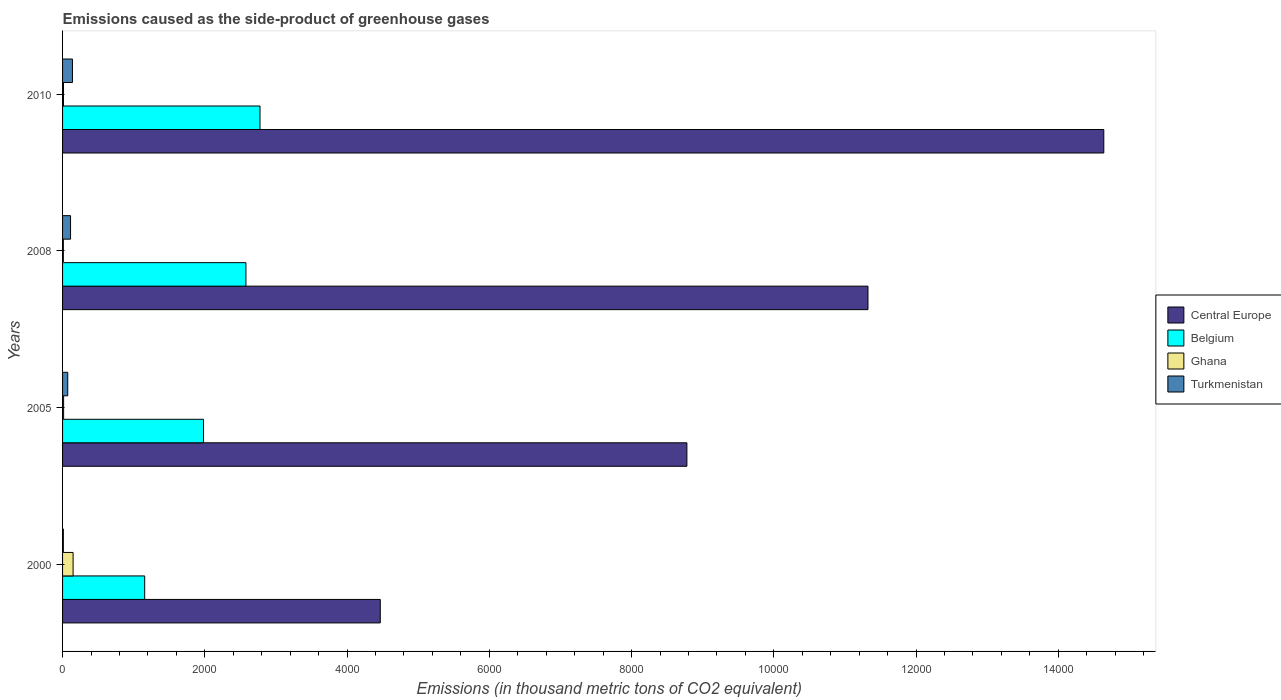How many different coloured bars are there?
Your answer should be very brief. 4. How many groups of bars are there?
Provide a succinct answer. 4. How many bars are there on the 3rd tick from the bottom?
Your response must be concise. 4. What is the emissions caused as the side-product of greenhouse gases in Belgium in 2000?
Ensure brevity in your answer.  1154.6. Across all years, what is the maximum emissions caused as the side-product of greenhouse gases in Ghana?
Your answer should be compact. 148. What is the total emissions caused as the side-product of greenhouse gases in Belgium in the graph?
Provide a succinct answer. 8489.8. What is the difference between the emissions caused as the side-product of greenhouse gases in Belgium in 2005 and that in 2008?
Your answer should be compact. -596.8. What is the difference between the emissions caused as the side-product of greenhouse gases in Ghana in 2010 and the emissions caused as the side-product of greenhouse gases in Central Europe in 2005?
Provide a short and direct response. -8764.6. What is the average emissions caused as the side-product of greenhouse gases in Belgium per year?
Your response must be concise. 2122.45. In the year 2000, what is the difference between the emissions caused as the side-product of greenhouse gases in Ghana and emissions caused as the side-product of greenhouse gases in Central Europe?
Provide a succinct answer. -4318.9. What is the ratio of the emissions caused as the side-product of greenhouse gases in Belgium in 2005 to that in 2010?
Make the answer very short. 0.71. Is the emissions caused as the side-product of greenhouse gases in Ghana in 2000 less than that in 2005?
Provide a short and direct response. No. Is the difference between the emissions caused as the side-product of greenhouse gases in Ghana in 2008 and 2010 greater than the difference between the emissions caused as the side-product of greenhouse gases in Central Europe in 2008 and 2010?
Provide a succinct answer. Yes. What is the difference between the highest and the second highest emissions caused as the side-product of greenhouse gases in Belgium?
Your response must be concise. 198. What is the difference between the highest and the lowest emissions caused as the side-product of greenhouse gases in Ghana?
Ensure brevity in your answer.  136.8. In how many years, is the emissions caused as the side-product of greenhouse gases in Belgium greater than the average emissions caused as the side-product of greenhouse gases in Belgium taken over all years?
Make the answer very short. 2. Is the sum of the emissions caused as the side-product of greenhouse gases in Turkmenistan in 2000 and 2010 greater than the maximum emissions caused as the side-product of greenhouse gases in Ghana across all years?
Offer a very short reply. Yes. Is it the case that in every year, the sum of the emissions caused as the side-product of greenhouse gases in Central Europe and emissions caused as the side-product of greenhouse gases in Belgium is greater than the sum of emissions caused as the side-product of greenhouse gases in Turkmenistan and emissions caused as the side-product of greenhouse gases in Ghana?
Offer a terse response. No. How many bars are there?
Your answer should be very brief. 16. Are all the bars in the graph horizontal?
Keep it short and to the point. Yes. How many years are there in the graph?
Your answer should be compact. 4. What is the difference between two consecutive major ticks on the X-axis?
Provide a succinct answer. 2000. Are the values on the major ticks of X-axis written in scientific E-notation?
Provide a short and direct response. No. Does the graph contain any zero values?
Make the answer very short. No. What is the title of the graph?
Offer a terse response. Emissions caused as the side-product of greenhouse gases. What is the label or title of the X-axis?
Provide a succinct answer. Emissions (in thousand metric tons of CO2 equivalent). What is the label or title of the Y-axis?
Provide a succinct answer. Years. What is the Emissions (in thousand metric tons of CO2 equivalent) in Central Europe in 2000?
Your response must be concise. 4466.9. What is the Emissions (in thousand metric tons of CO2 equivalent) in Belgium in 2000?
Keep it short and to the point. 1154.6. What is the Emissions (in thousand metric tons of CO2 equivalent) of Ghana in 2000?
Your response must be concise. 148. What is the Emissions (in thousand metric tons of CO2 equivalent) of Central Europe in 2005?
Offer a terse response. 8777.6. What is the Emissions (in thousand metric tons of CO2 equivalent) of Belgium in 2005?
Give a very brief answer. 1981.2. What is the Emissions (in thousand metric tons of CO2 equivalent) in Turkmenistan in 2005?
Your answer should be compact. 72.9. What is the Emissions (in thousand metric tons of CO2 equivalent) in Central Europe in 2008?
Ensure brevity in your answer.  1.13e+04. What is the Emissions (in thousand metric tons of CO2 equivalent) of Belgium in 2008?
Provide a short and direct response. 2578. What is the Emissions (in thousand metric tons of CO2 equivalent) in Turkmenistan in 2008?
Your response must be concise. 112.2. What is the Emissions (in thousand metric tons of CO2 equivalent) in Central Europe in 2010?
Offer a very short reply. 1.46e+04. What is the Emissions (in thousand metric tons of CO2 equivalent) in Belgium in 2010?
Offer a very short reply. 2776. What is the Emissions (in thousand metric tons of CO2 equivalent) of Turkmenistan in 2010?
Make the answer very short. 139. Across all years, what is the maximum Emissions (in thousand metric tons of CO2 equivalent) of Central Europe?
Ensure brevity in your answer.  1.46e+04. Across all years, what is the maximum Emissions (in thousand metric tons of CO2 equivalent) of Belgium?
Your answer should be compact. 2776. Across all years, what is the maximum Emissions (in thousand metric tons of CO2 equivalent) in Ghana?
Make the answer very short. 148. Across all years, what is the maximum Emissions (in thousand metric tons of CO2 equivalent) of Turkmenistan?
Give a very brief answer. 139. Across all years, what is the minimum Emissions (in thousand metric tons of CO2 equivalent) of Central Europe?
Offer a very short reply. 4466.9. Across all years, what is the minimum Emissions (in thousand metric tons of CO2 equivalent) in Belgium?
Your answer should be compact. 1154.6. Across all years, what is the minimum Emissions (in thousand metric tons of CO2 equivalent) of Turkmenistan?
Give a very brief answer. 10.9. What is the total Emissions (in thousand metric tons of CO2 equivalent) in Central Europe in the graph?
Keep it short and to the point. 3.92e+04. What is the total Emissions (in thousand metric tons of CO2 equivalent) in Belgium in the graph?
Provide a succinct answer. 8489.8. What is the total Emissions (in thousand metric tons of CO2 equivalent) of Ghana in the graph?
Offer a very short reply. 186.9. What is the total Emissions (in thousand metric tons of CO2 equivalent) in Turkmenistan in the graph?
Offer a very short reply. 335. What is the difference between the Emissions (in thousand metric tons of CO2 equivalent) of Central Europe in 2000 and that in 2005?
Provide a succinct answer. -4310.7. What is the difference between the Emissions (in thousand metric tons of CO2 equivalent) in Belgium in 2000 and that in 2005?
Keep it short and to the point. -826.6. What is the difference between the Emissions (in thousand metric tons of CO2 equivalent) in Ghana in 2000 and that in 2005?
Your answer should be compact. 133.3. What is the difference between the Emissions (in thousand metric tons of CO2 equivalent) in Turkmenistan in 2000 and that in 2005?
Make the answer very short. -62. What is the difference between the Emissions (in thousand metric tons of CO2 equivalent) in Central Europe in 2000 and that in 2008?
Your answer should be compact. -6856.5. What is the difference between the Emissions (in thousand metric tons of CO2 equivalent) of Belgium in 2000 and that in 2008?
Your response must be concise. -1423.4. What is the difference between the Emissions (in thousand metric tons of CO2 equivalent) of Ghana in 2000 and that in 2008?
Your answer should be compact. 136.8. What is the difference between the Emissions (in thousand metric tons of CO2 equivalent) of Turkmenistan in 2000 and that in 2008?
Keep it short and to the point. -101.3. What is the difference between the Emissions (in thousand metric tons of CO2 equivalent) in Central Europe in 2000 and that in 2010?
Provide a short and direct response. -1.02e+04. What is the difference between the Emissions (in thousand metric tons of CO2 equivalent) in Belgium in 2000 and that in 2010?
Give a very brief answer. -1621.4. What is the difference between the Emissions (in thousand metric tons of CO2 equivalent) of Ghana in 2000 and that in 2010?
Make the answer very short. 135. What is the difference between the Emissions (in thousand metric tons of CO2 equivalent) in Turkmenistan in 2000 and that in 2010?
Your response must be concise. -128.1. What is the difference between the Emissions (in thousand metric tons of CO2 equivalent) of Central Europe in 2005 and that in 2008?
Provide a succinct answer. -2545.8. What is the difference between the Emissions (in thousand metric tons of CO2 equivalent) of Belgium in 2005 and that in 2008?
Your answer should be compact. -596.8. What is the difference between the Emissions (in thousand metric tons of CO2 equivalent) in Ghana in 2005 and that in 2008?
Keep it short and to the point. 3.5. What is the difference between the Emissions (in thousand metric tons of CO2 equivalent) in Turkmenistan in 2005 and that in 2008?
Offer a very short reply. -39.3. What is the difference between the Emissions (in thousand metric tons of CO2 equivalent) of Central Europe in 2005 and that in 2010?
Offer a terse response. -5861.4. What is the difference between the Emissions (in thousand metric tons of CO2 equivalent) of Belgium in 2005 and that in 2010?
Your response must be concise. -794.8. What is the difference between the Emissions (in thousand metric tons of CO2 equivalent) in Ghana in 2005 and that in 2010?
Give a very brief answer. 1.7. What is the difference between the Emissions (in thousand metric tons of CO2 equivalent) of Turkmenistan in 2005 and that in 2010?
Your answer should be compact. -66.1. What is the difference between the Emissions (in thousand metric tons of CO2 equivalent) in Central Europe in 2008 and that in 2010?
Keep it short and to the point. -3315.6. What is the difference between the Emissions (in thousand metric tons of CO2 equivalent) of Belgium in 2008 and that in 2010?
Offer a terse response. -198. What is the difference between the Emissions (in thousand metric tons of CO2 equivalent) of Ghana in 2008 and that in 2010?
Provide a short and direct response. -1.8. What is the difference between the Emissions (in thousand metric tons of CO2 equivalent) in Turkmenistan in 2008 and that in 2010?
Your answer should be compact. -26.8. What is the difference between the Emissions (in thousand metric tons of CO2 equivalent) in Central Europe in 2000 and the Emissions (in thousand metric tons of CO2 equivalent) in Belgium in 2005?
Keep it short and to the point. 2485.7. What is the difference between the Emissions (in thousand metric tons of CO2 equivalent) in Central Europe in 2000 and the Emissions (in thousand metric tons of CO2 equivalent) in Ghana in 2005?
Give a very brief answer. 4452.2. What is the difference between the Emissions (in thousand metric tons of CO2 equivalent) in Central Europe in 2000 and the Emissions (in thousand metric tons of CO2 equivalent) in Turkmenistan in 2005?
Offer a terse response. 4394. What is the difference between the Emissions (in thousand metric tons of CO2 equivalent) of Belgium in 2000 and the Emissions (in thousand metric tons of CO2 equivalent) of Ghana in 2005?
Offer a very short reply. 1139.9. What is the difference between the Emissions (in thousand metric tons of CO2 equivalent) in Belgium in 2000 and the Emissions (in thousand metric tons of CO2 equivalent) in Turkmenistan in 2005?
Give a very brief answer. 1081.7. What is the difference between the Emissions (in thousand metric tons of CO2 equivalent) of Ghana in 2000 and the Emissions (in thousand metric tons of CO2 equivalent) of Turkmenistan in 2005?
Give a very brief answer. 75.1. What is the difference between the Emissions (in thousand metric tons of CO2 equivalent) of Central Europe in 2000 and the Emissions (in thousand metric tons of CO2 equivalent) of Belgium in 2008?
Ensure brevity in your answer.  1888.9. What is the difference between the Emissions (in thousand metric tons of CO2 equivalent) of Central Europe in 2000 and the Emissions (in thousand metric tons of CO2 equivalent) of Ghana in 2008?
Offer a terse response. 4455.7. What is the difference between the Emissions (in thousand metric tons of CO2 equivalent) of Central Europe in 2000 and the Emissions (in thousand metric tons of CO2 equivalent) of Turkmenistan in 2008?
Your response must be concise. 4354.7. What is the difference between the Emissions (in thousand metric tons of CO2 equivalent) of Belgium in 2000 and the Emissions (in thousand metric tons of CO2 equivalent) of Ghana in 2008?
Provide a short and direct response. 1143.4. What is the difference between the Emissions (in thousand metric tons of CO2 equivalent) of Belgium in 2000 and the Emissions (in thousand metric tons of CO2 equivalent) of Turkmenistan in 2008?
Your answer should be very brief. 1042.4. What is the difference between the Emissions (in thousand metric tons of CO2 equivalent) in Ghana in 2000 and the Emissions (in thousand metric tons of CO2 equivalent) in Turkmenistan in 2008?
Offer a terse response. 35.8. What is the difference between the Emissions (in thousand metric tons of CO2 equivalent) of Central Europe in 2000 and the Emissions (in thousand metric tons of CO2 equivalent) of Belgium in 2010?
Ensure brevity in your answer.  1690.9. What is the difference between the Emissions (in thousand metric tons of CO2 equivalent) in Central Europe in 2000 and the Emissions (in thousand metric tons of CO2 equivalent) in Ghana in 2010?
Keep it short and to the point. 4453.9. What is the difference between the Emissions (in thousand metric tons of CO2 equivalent) of Central Europe in 2000 and the Emissions (in thousand metric tons of CO2 equivalent) of Turkmenistan in 2010?
Make the answer very short. 4327.9. What is the difference between the Emissions (in thousand metric tons of CO2 equivalent) of Belgium in 2000 and the Emissions (in thousand metric tons of CO2 equivalent) of Ghana in 2010?
Provide a short and direct response. 1141.6. What is the difference between the Emissions (in thousand metric tons of CO2 equivalent) of Belgium in 2000 and the Emissions (in thousand metric tons of CO2 equivalent) of Turkmenistan in 2010?
Your answer should be compact. 1015.6. What is the difference between the Emissions (in thousand metric tons of CO2 equivalent) in Ghana in 2000 and the Emissions (in thousand metric tons of CO2 equivalent) in Turkmenistan in 2010?
Your answer should be very brief. 9. What is the difference between the Emissions (in thousand metric tons of CO2 equivalent) in Central Europe in 2005 and the Emissions (in thousand metric tons of CO2 equivalent) in Belgium in 2008?
Your answer should be compact. 6199.6. What is the difference between the Emissions (in thousand metric tons of CO2 equivalent) of Central Europe in 2005 and the Emissions (in thousand metric tons of CO2 equivalent) of Ghana in 2008?
Ensure brevity in your answer.  8766.4. What is the difference between the Emissions (in thousand metric tons of CO2 equivalent) in Central Europe in 2005 and the Emissions (in thousand metric tons of CO2 equivalent) in Turkmenistan in 2008?
Make the answer very short. 8665.4. What is the difference between the Emissions (in thousand metric tons of CO2 equivalent) of Belgium in 2005 and the Emissions (in thousand metric tons of CO2 equivalent) of Ghana in 2008?
Offer a terse response. 1970. What is the difference between the Emissions (in thousand metric tons of CO2 equivalent) in Belgium in 2005 and the Emissions (in thousand metric tons of CO2 equivalent) in Turkmenistan in 2008?
Offer a very short reply. 1869. What is the difference between the Emissions (in thousand metric tons of CO2 equivalent) in Ghana in 2005 and the Emissions (in thousand metric tons of CO2 equivalent) in Turkmenistan in 2008?
Ensure brevity in your answer.  -97.5. What is the difference between the Emissions (in thousand metric tons of CO2 equivalent) of Central Europe in 2005 and the Emissions (in thousand metric tons of CO2 equivalent) of Belgium in 2010?
Your answer should be compact. 6001.6. What is the difference between the Emissions (in thousand metric tons of CO2 equivalent) of Central Europe in 2005 and the Emissions (in thousand metric tons of CO2 equivalent) of Ghana in 2010?
Your response must be concise. 8764.6. What is the difference between the Emissions (in thousand metric tons of CO2 equivalent) of Central Europe in 2005 and the Emissions (in thousand metric tons of CO2 equivalent) of Turkmenistan in 2010?
Your response must be concise. 8638.6. What is the difference between the Emissions (in thousand metric tons of CO2 equivalent) of Belgium in 2005 and the Emissions (in thousand metric tons of CO2 equivalent) of Ghana in 2010?
Provide a succinct answer. 1968.2. What is the difference between the Emissions (in thousand metric tons of CO2 equivalent) of Belgium in 2005 and the Emissions (in thousand metric tons of CO2 equivalent) of Turkmenistan in 2010?
Your response must be concise. 1842.2. What is the difference between the Emissions (in thousand metric tons of CO2 equivalent) of Ghana in 2005 and the Emissions (in thousand metric tons of CO2 equivalent) of Turkmenistan in 2010?
Ensure brevity in your answer.  -124.3. What is the difference between the Emissions (in thousand metric tons of CO2 equivalent) of Central Europe in 2008 and the Emissions (in thousand metric tons of CO2 equivalent) of Belgium in 2010?
Give a very brief answer. 8547.4. What is the difference between the Emissions (in thousand metric tons of CO2 equivalent) of Central Europe in 2008 and the Emissions (in thousand metric tons of CO2 equivalent) of Ghana in 2010?
Your answer should be very brief. 1.13e+04. What is the difference between the Emissions (in thousand metric tons of CO2 equivalent) in Central Europe in 2008 and the Emissions (in thousand metric tons of CO2 equivalent) in Turkmenistan in 2010?
Offer a terse response. 1.12e+04. What is the difference between the Emissions (in thousand metric tons of CO2 equivalent) in Belgium in 2008 and the Emissions (in thousand metric tons of CO2 equivalent) in Ghana in 2010?
Keep it short and to the point. 2565. What is the difference between the Emissions (in thousand metric tons of CO2 equivalent) of Belgium in 2008 and the Emissions (in thousand metric tons of CO2 equivalent) of Turkmenistan in 2010?
Make the answer very short. 2439. What is the difference between the Emissions (in thousand metric tons of CO2 equivalent) in Ghana in 2008 and the Emissions (in thousand metric tons of CO2 equivalent) in Turkmenistan in 2010?
Keep it short and to the point. -127.8. What is the average Emissions (in thousand metric tons of CO2 equivalent) in Central Europe per year?
Ensure brevity in your answer.  9801.73. What is the average Emissions (in thousand metric tons of CO2 equivalent) in Belgium per year?
Your answer should be very brief. 2122.45. What is the average Emissions (in thousand metric tons of CO2 equivalent) in Ghana per year?
Provide a short and direct response. 46.73. What is the average Emissions (in thousand metric tons of CO2 equivalent) in Turkmenistan per year?
Your answer should be very brief. 83.75. In the year 2000, what is the difference between the Emissions (in thousand metric tons of CO2 equivalent) in Central Europe and Emissions (in thousand metric tons of CO2 equivalent) in Belgium?
Keep it short and to the point. 3312.3. In the year 2000, what is the difference between the Emissions (in thousand metric tons of CO2 equivalent) of Central Europe and Emissions (in thousand metric tons of CO2 equivalent) of Ghana?
Provide a short and direct response. 4318.9. In the year 2000, what is the difference between the Emissions (in thousand metric tons of CO2 equivalent) of Central Europe and Emissions (in thousand metric tons of CO2 equivalent) of Turkmenistan?
Offer a terse response. 4456. In the year 2000, what is the difference between the Emissions (in thousand metric tons of CO2 equivalent) of Belgium and Emissions (in thousand metric tons of CO2 equivalent) of Ghana?
Offer a terse response. 1006.6. In the year 2000, what is the difference between the Emissions (in thousand metric tons of CO2 equivalent) of Belgium and Emissions (in thousand metric tons of CO2 equivalent) of Turkmenistan?
Ensure brevity in your answer.  1143.7. In the year 2000, what is the difference between the Emissions (in thousand metric tons of CO2 equivalent) of Ghana and Emissions (in thousand metric tons of CO2 equivalent) of Turkmenistan?
Provide a succinct answer. 137.1. In the year 2005, what is the difference between the Emissions (in thousand metric tons of CO2 equivalent) in Central Europe and Emissions (in thousand metric tons of CO2 equivalent) in Belgium?
Offer a terse response. 6796.4. In the year 2005, what is the difference between the Emissions (in thousand metric tons of CO2 equivalent) in Central Europe and Emissions (in thousand metric tons of CO2 equivalent) in Ghana?
Offer a very short reply. 8762.9. In the year 2005, what is the difference between the Emissions (in thousand metric tons of CO2 equivalent) in Central Europe and Emissions (in thousand metric tons of CO2 equivalent) in Turkmenistan?
Your response must be concise. 8704.7. In the year 2005, what is the difference between the Emissions (in thousand metric tons of CO2 equivalent) of Belgium and Emissions (in thousand metric tons of CO2 equivalent) of Ghana?
Keep it short and to the point. 1966.5. In the year 2005, what is the difference between the Emissions (in thousand metric tons of CO2 equivalent) of Belgium and Emissions (in thousand metric tons of CO2 equivalent) of Turkmenistan?
Ensure brevity in your answer.  1908.3. In the year 2005, what is the difference between the Emissions (in thousand metric tons of CO2 equivalent) of Ghana and Emissions (in thousand metric tons of CO2 equivalent) of Turkmenistan?
Your answer should be compact. -58.2. In the year 2008, what is the difference between the Emissions (in thousand metric tons of CO2 equivalent) of Central Europe and Emissions (in thousand metric tons of CO2 equivalent) of Belgium?
Your answer should be very brief. 8745.4. In the year 2008, what is the difference between the Emissions (in thousand metric tons of CO2 equivalent) of Central Europe and Emissions (in thousand metric tons of CO2 equivalent) of Ghana?
Give a very brief answer. 1.13e+04. In the year 2008, what is the difference between the Emissions (in thousand metric tons of CO2 equivalent) in Central Europe and Emissions (in thousand metric tons of CO2 equivalent) in Turkmenistan?
Offer a terse response. 1.12e+04. In the year 2008, what is the difference between the Emissions (in thousand metric tons of CO2 equivalent) in Belgium and Emissions (in thousand metric tons of CO2 equivalent) in Ghana?
Keep it short and to the point. 2566.8. In the year 2008, what is the difference between the Emissions (in thousand metric tons of CO2 equivalent) of Belgium and Emissions (in thousand metric tons of CO2 equivalent) of Turkmenistan?
Keep it short and to the point. 2465.8. In the year 2008, what is the difference between the Emissions (in thousand metric tons of CO2 equivalent) in Ghana and Emissions (in thousand metric tons of CO2 equivalent) in Turkmenistan?
Offer a terse response. -101. In the year 2010, what is the difference between the Emissions (in thousand metric tons of CO2 equivalent) in Central Europe and Emissions (in thousand metric tons of CO2 equivalent) in Belgium?
Offer a terse response. 1.19e+04. In the year 2010, what is the difference between the Emissions (in thousand metric tons of CO2 equivalent) in Central Europe and Emissions (in thousand metric tons of CO2 equivalent) in Ghana?
Make the answer very short. 1.46e+04. In the year 2010, what is the difference between the Emissions (in thousand metric tons of CO2 equivalent) of Central Europe and Emissions (in thousand metric tons of CO2 equivalent) of Turkmenistan?
Offer a very short reply. 1.45e+04. In the year 2010, what is the difference between the Emissions (in thousand metric tons of CO2 equivalent) in Belgium and Emissions (in thousand metric tons of CO2 equivalent) in Ghana?
Your answer should be very brief. 2763. In the year 2010, what is the difference between the Emissions (in thousand metric tons of CO2 equivalent) of Belgium and Emissions (in thousand metric tons of CO2 equivalent) of Turkmenistan?
Your response must be concise. 2637. In the year 2010, what is the difference between the Emissions (in thousand metric tons of CO2 equivalent) in Ghana and Emissions (in thousand metric tons of CO2 equivalent) in Turkmenistan?
Your answer should be very brief. -126. What is the ratio of the Emissions (in thousand metric tons of CO2 equivalent) of Central Europe in 2000 to that in 2005?
Your response must be concise. 0.51. What is the ratio of the Emissions (in thousand metric tons of CO2 equivalent) in Belgium in 2000 to that in 2005?
Offer a terse response. 0.58. What is the ratio of the Emissions (in thousand metric tons of CO2 equivalent) in Ghana in 2000 to that in 2005?
Your answer should be compact. 10.07. What is the ratio of the Emissions (in thousand metric tons of CO2 equivalent) in Turkmenistan in 2000 to that in 2005?
Offer a terse response. 0.15. What is the ratio of the Emissions (in thousand metric tons of CO2 equivalent) in Central Europe in 2000 to that in 2008?
Provide a short and direct response. 0.39. What is the ratio of the Emissions (in thousand metric tons of CO2 equivalent) in Belgium in 2000 to that in 2008?
Offer a very short reply. 0.45. What is the ratio of the Emissions (in thousand metric tons of CO2 equivalent) in Ghana in 2000 to that in 2008?
Your answer should be very brief. 13.21. What is the ratio of the Emissions (in thousand metric tons of CO2 equivalent) in Turkmenistan in 2000 to that in 2008?
Your response must be concise. 0.1. What is the ratio of the Emissions (in thousand metric tons of CO2 equivalent) of Central Europe in 2000 to that in 2010?
Your answer should be very brief. 0.31. What is the ratio of the Emissions (in thousand metric tons of CO2 equivalent) of Belgium in 2000 to that in 2010?
Ensure brevity in your answer.  0.42. What is the ratio of the Emissions (in thousand metric tons of CO2 equivalent) in Ghana in 2000 to that in 2010?
Provide a succinct answer. 11.38. What is the ratio of the Emissions (in thousand metric tons of CO2 equivalent) in Turkmenistan in 2000 to that in 2010?
Give a very brief answer. 0.08. What is the ratio of the Emissions (in thousand metric tons of CO2 equivalent) in Central Europe in 2005 to that in 2008?
Ensure brevity in your answer.  0.78. What is the ratio of the Emissions (in thousand metric tons of CO2 equivalent) of Belgium in 2005 to that in 2008?
Keep it short and to the point. 0.77. What is the ratio of the Emissions (in thousand metric tons of CO2 equivalent) of Ghana in 2005 to that in 2008?
Give a very brief answer. 1.31. What is the ratio of the Emissions (in thousand metric tons of CO2 equivalent) in Turkmenistan in 2005 to that in 2008?
Provide a succinct answer. 0.65. What is the ratio of the Emissions (in thousand metric tons of CO2 equivalent) in Central Europe in 2005 to that in 2010?
Your answer should be compact. 0.6. What is the ratio of the Emissions (in thousand metric tons of CO2 equivalent) in Belgium in 2005 to that in 2010?
Provide a short and direct response. 0.71. What is the ratio of the Emissions (in thousand metric tons of CO2 equivalent) in Ghana in 2005 to that in 2010?
Your answer should be compact. 1.13. What is the ratio of the Emissions (in thousand metric tons of CO2 equivalent) in Turkmenistan in 2005 to that in 2010?
Offer a very short reply. 0.52. What is the ratio of the Emissions (in thousand metric tons of CO2 equivalent) of Central Europe in 2008 to that in 2010?
Your response must be concise. 0.77. What is the ratio of the Emissions (in thousand metric tons of CO2 equivalent) of Belgium in 2008 to that in 2010?
Your answer should be very brief. 0.93. What is the ratio of the Emissions (in thousand metric tons of CO2 equivalent) in Ghana in 2008 to that in 2010?
Make the answer very short. 0.86. What is the ratio of the Emissions (in thousand metric tons of CO2 equivalent) of Turkmenistan in 2008 to that in 2010?
Provide a short and direct response. 0.81. What is the difference between the highest and the second highest Emissions (in thousand metric tons of CO2 equivalent) in Central Europe?
Offer a very short reply. 3315.6. What is the difference between the highest and the second highest Emissions (in thousand metric tons of CO2 equivalent) in Belgium?
Provide a short and direct response. 198. What is the difference between the highest and the second highest Emissions (in thousand metric tons of CO2 equivalent) of Ghana?
Your answer should be very brief. 133.3. What is the difference between the highest and the second highest Emissions (in thousand metric tons of CO2 equivalent) in Turkmenistan?
Offer a very short reply. 26.8. What is the difference between the highest and the lowest Emissions (in thousand metric tons of CO2 equivalent) of Central Europe?
Provide a short and direct response. 1.02e+04. What is the difference between the highest and the lowest Emissions (in thousand metric tons of CO2 equivalent) in Belgium?
Provide a succinct answer. 1621.4. What is the difference between the highest and the lowest Emissions (in thousand metric tons of CO2 equivalent) in Ghana?
Provide a short and direct response. 136.8. What is the difference between the highest and the lowest Emissions (in thousand metric tons of CO2 equivalent) in Turkmenistan?
Your answer should be compact. 128.1. 